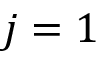Convert formula to latex. <formula><loc_0><loc_0><loc_500><loc_500>j = 1</formula> 